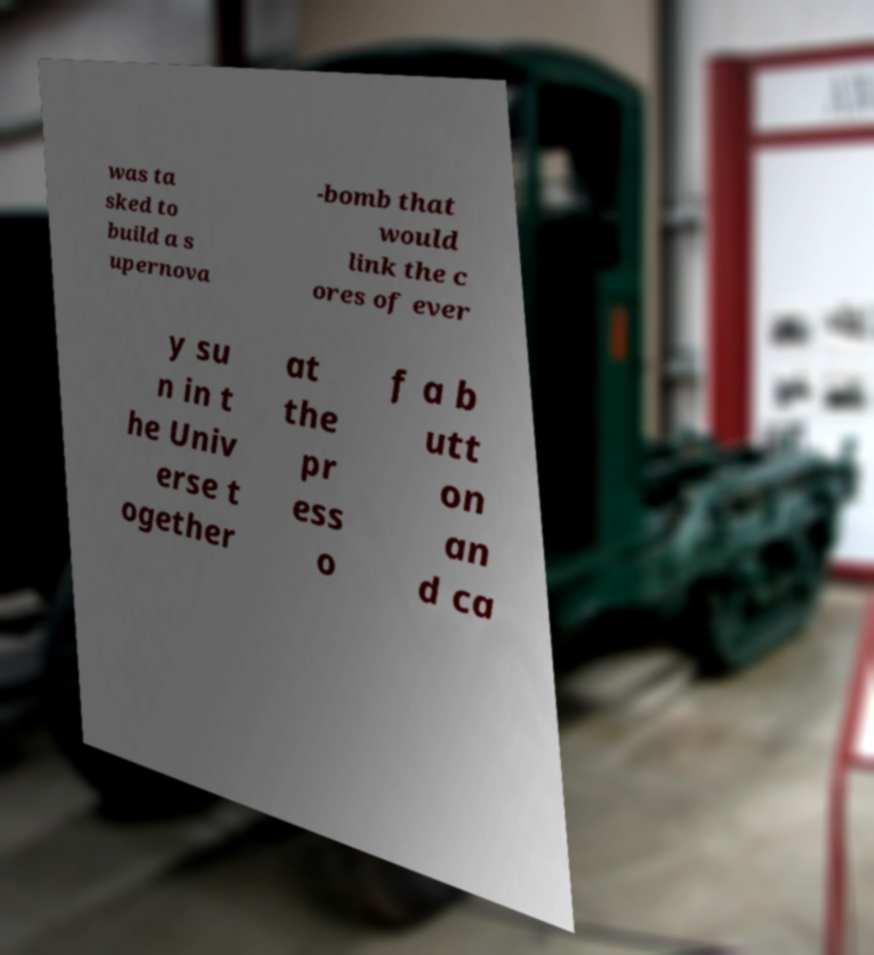Please read and relay the text visible in this image. What does it say? was ta sked to build a s upernova -bomb that would link the c ores of ever y su n in t he Univ erse t ogether at the pr ess o f a b utt on an d ca 